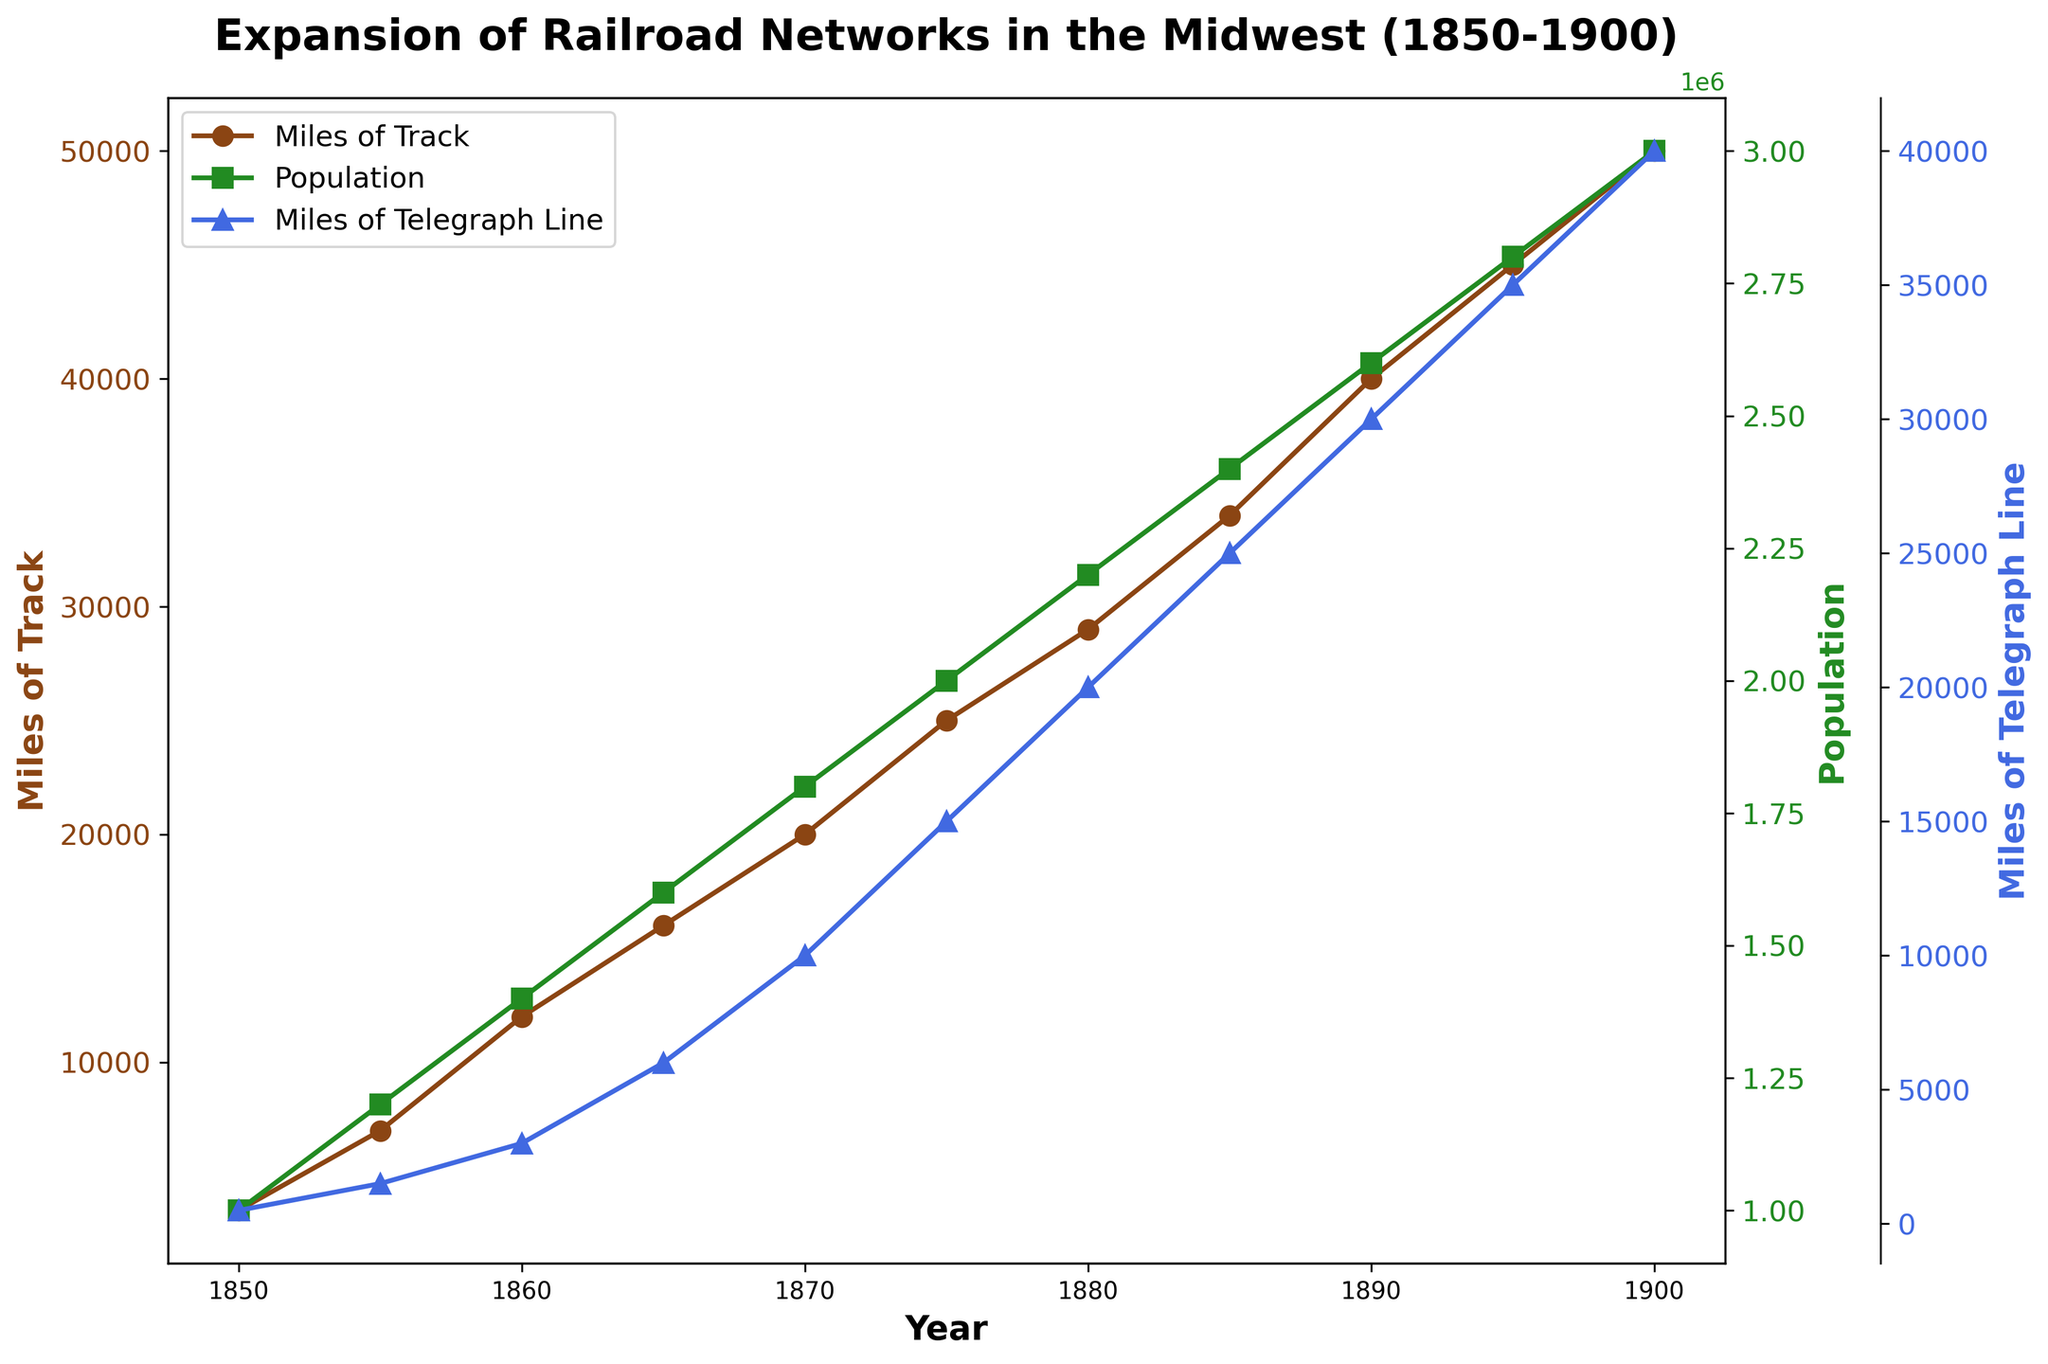When did the miles of telegraph line first reach 10,000 miles? In the figure, trace the timeline for the Miles of Telegraph Line series until it crosses the 10,000 mark and observe the corresponding year.
Answer: 1870 How many times did the population increase from 1850 to 1900? Compare the population values in 1850 and 1900. Population in 1850 is 1,000,000, and in 1900 it is 3,000,000. Therefore, the population increased three times.
Answer: 3 times Did businesses established grow faster in the 1850s or in the 1870s? Calculate the growth in businesses established during each decade. From 1850 to 1860, businesses increased from 150 to 600, which is an increase of 450. From 1870 to 1880, businesses increased from 1500 to 2100, which is an increase of 600.
Answer: 1870s Which metric shows the most significant change in the decade between 1890 and 1900? Compare the changes for all metrics during this period: Miles of Track (50,000 - 40,000 = 10,000), Population (3,000,000 - 2,600,000 = 400,000), and Miles of Telegraph Line (40,000 - 30,000 = 10,000). All metrics changed significantly by 10,000 each, so there's no single metric with a more significant change.
Answer: All metrics changed equally What year did the miles of track exceed 20,000? Observe the year in which the figure for Miles of Track crosses 20,000. This occurs in the year 1870.
Answer: 1870 Compare the growth rates of railroads and telegraph lines between 1855 to 1865? Determine the growth for each metric: Miles of Track (16,000 - 7,000 = 9,000) and Miles of Telegraph Line (6,000 - 1,500 = 4,500) over the same period of 10 years.
Answer: Railroad growth is 9,000 miles; telegraph line growth is 4,500 miles In which year were the most significant gains in population recorded? Analyze the plot for Population to identify which year shows the steepest increase. The period from 1880 to 1885 shows an increase from 2,200,000 to 2,400,000, the same increase of 200,000 is also seen between 1895 and 1900.
Answer: 1880-1885, 1895-1900 Which data series consistently showed positive growth throughout the timeframe? Verify each plotted series: Miles of Track, Population, and Miles of Telegraph Line to see if each constantly exhibited upward trends without downward dips.
Answer: All data series 